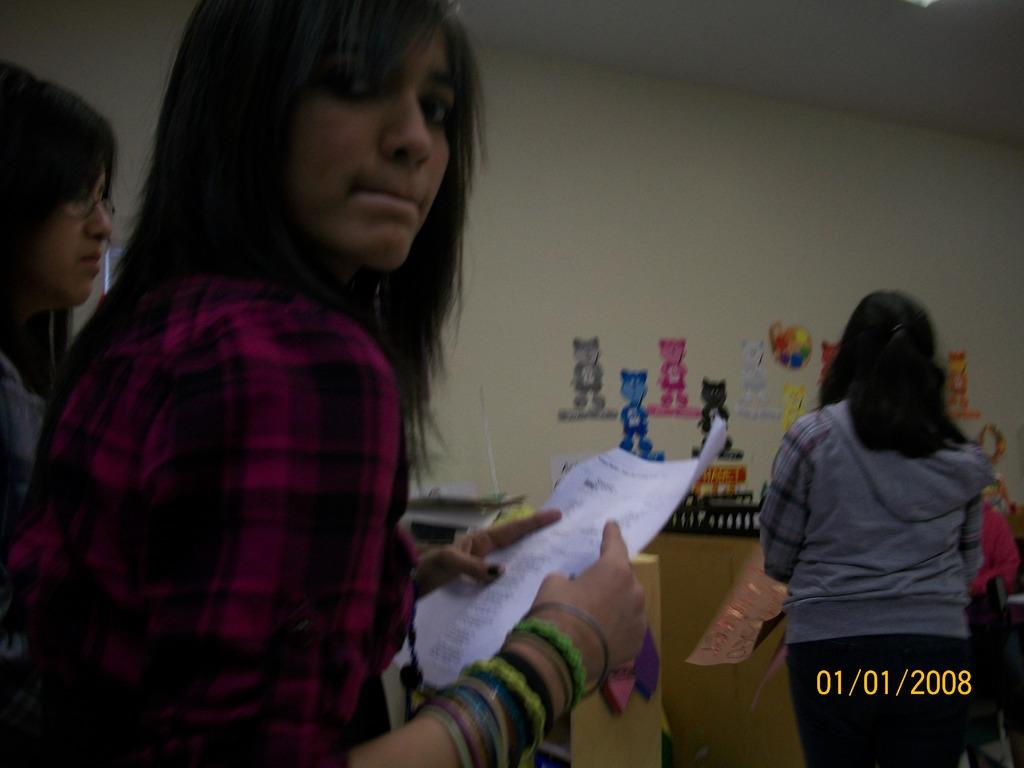What year was this photo taken?
Your response must be concise. 2008. 